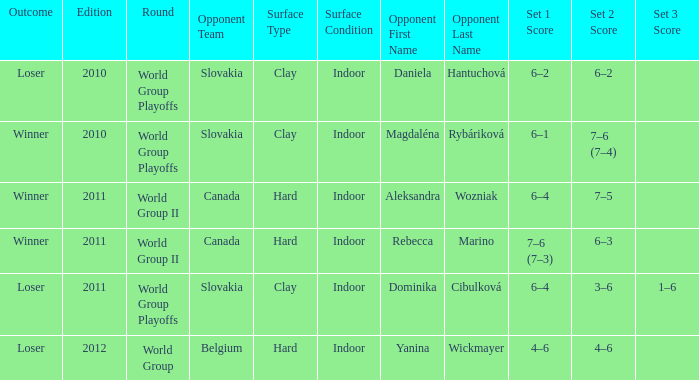What transpired in the game when the competitor was magdaléna rybáriková? Winner. 